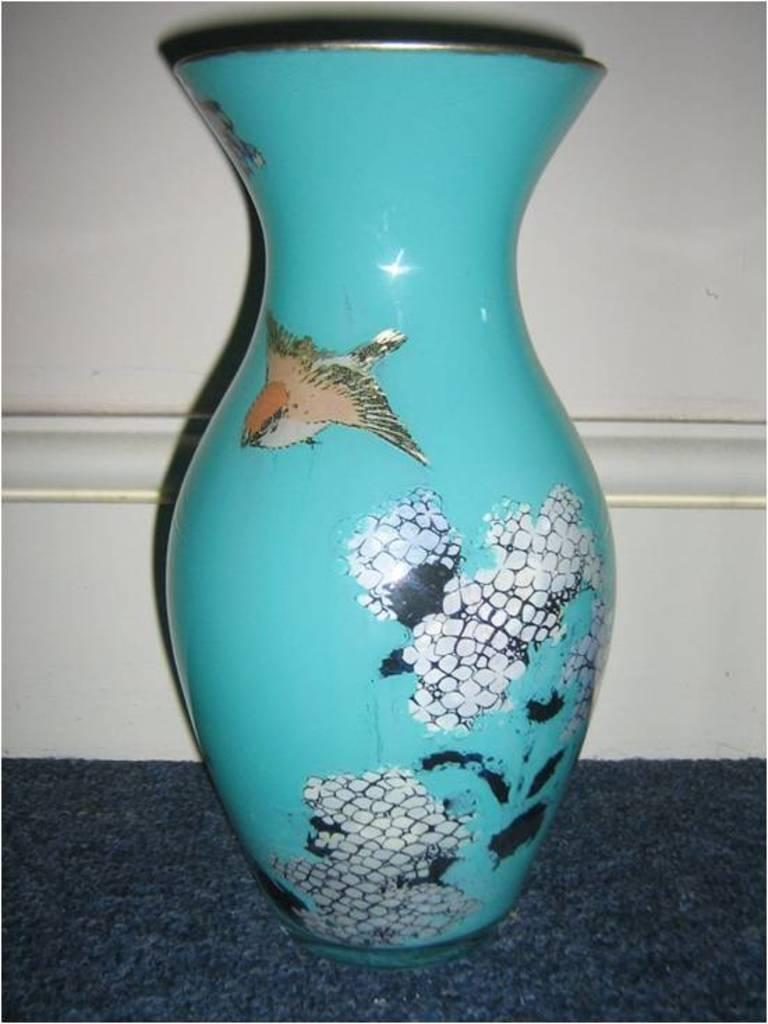What color is the vase in the image? The vase in the image is blue. What color is the background of the image? The background of the image is white. Are there any toys visible in the image? There is no mention of toys in the provided facts, so we cannot determine if any are present in the image. 